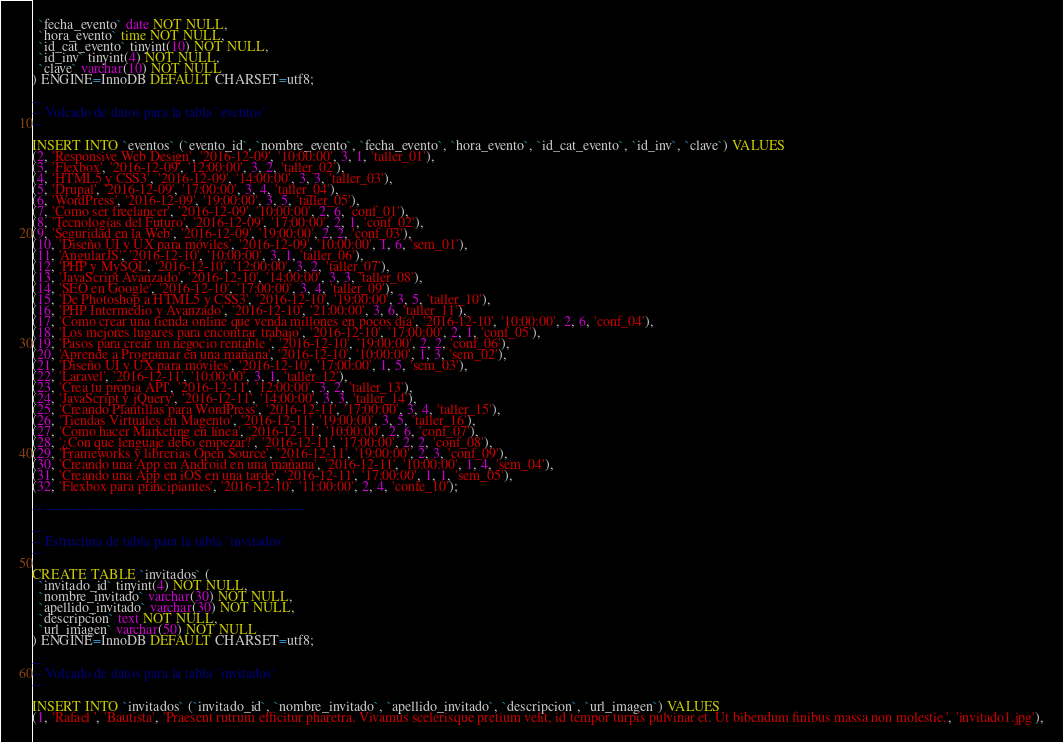Convert code to text. <code><loc_0><loc_0><loc_500><loc_500><_SQL_>  `fecha_evento` date NOT NULL,
  `hora_evento` time NOT NULL,
  `id_cat_evento` tinyint(10) NOT NULL,
  `id_inv` tinyint(4) NOT NULL,
  `clave` varchar(10) NOT NULL
) ENGINE=InnoDB DEFAULT CHARSET=utf8;

--
-- Volcado de datos para la tabla `eventos`
--

INSERT INTO `eventos` (`evento_id`, `nombre_evento`, `fecha_evento`, `hora_evento`, `id_cat_evento`, `id_inv`, `clave`) VALUES
(2, 'Responsive Web Design', '2016-12-09', '10:00:00', 3, 1, 'taller_01'),
(3, 'Flexbox', '2016-12-09', '12:00:00', 3, 2, 'taller_02'),
(4, 'HTML5 y CSS3', '2016-12-09', '14:00:00', 3, 3, 'taller_03'),
(5, 'Drupal', '2016-12-09', '17:00:00', 3, 4, 'taller_04'),
(6, 'WordPress', '2016-12-09', '19:00:00', 3, 5, 'taller_05'),
(7, 'Como ser freelancer', '2016-12-09', '10:00:00', 2, 6, 'conf_01'),
(8, 'Tecnologías del Futuro', '2016-12-09', '17:00:00', 2, 1, 'conf_02'),
(9, 'Seguridad en la Web', '2016-12-09', '19:00:00', 2, 2, 'conf_03'),
(10, 'Diseño UI y UX para móviles', '2016-12-09', '10:00:00', 1, 6, 'sem_01'),
(11, 'AngularJS', '2016-12-10', '10:00:00', 3, 1, 'taller_06'),
(12, 'PHP y MySQL', '2016-12-10', '12:00:00', 3, 2, 'taller_07'),
(13, 'JavaScript Avanzado', '2016-12-10', '14:00:00', 3, 3, 'taller_08'),
(14, 'SEO en Google', '2016-12-10', '17:00:00', 3, 4, 'taller_09'),
(15, 'De Photoshop a HTML5 y CSS3', '2016-12-10', '19:00:00', 3, 5, 'taller_10'),
(16, 'PHP Intermedio y Avanzado', '2016-12-10', '21:00:00', 3, 6, 'taller_11'),
(17, 'Como crear una tienda online que venda millones en pocos día', '2016-12-10', '10:00:00', 2, 6, 'conf_04'),
(18, 'Los mejores lugares para encontrar trabajo', '2016-12-10', '17:00:00', 2, 1, 'conf_05'),
(19, 'Pasos para crear un negocio rentable ', '2016-12-10', '19:00:00', 2, 2, 'conf_06'),
(20, 'Aprende a Programar en una mañana', '2016-12-10', '10:00:00', 1, 3, 'sem_02'),
(21, 'Diseño UI y UX para móviles', '2016-12-10', '17:00:00', 1, 5, 'sem_03'),
(22, 'Laravel', '2016-12-11', '10:00:00', 3, 1, 'taller_12'),
(23, 'Crea tu propia API', '2016-12-11', '12:00:00', 3, 2, 'taller_13'),
(24, 'JavaScript y jQuery', '2016-12-11', '14:00:00', 3, 3, 'taller_14'),
(25, 'Creando Plantillas para WordPress', '2016-12-11', '17:00:00', 3, 4, 'taller_15'),
(26, 'Tiendas Virtuales en Magento', '2016-12-11', '19:00:00', 3, 5, 'taller_16'),
(27, 'Como hacer Marketing en línea', '2016-12-11', '10:00:00', 2, 6, 'conf_07'),
(28, '¿Con que lenguaje debo empezar?', '2016-12-11', '17:00:00', 2, 2, 'conf_08'),
(29, 'Frameworks y librerias Open Source', '2016-12-11', '19:00:00', 2, 3, 'conf_09'),
(30, 'Creando una App en Android en una mañana', '2016-12-11', '10:00:00', 1, 4, 'sem_04'),
(31, 'Creando una App en iOS en una tarde', '2016-12-11', '17:00:00', 1, 1, 'sem_05'),
(32, 'Flexbox para principiantes', '2016-12-10', '11:00:00', 2, 4, 'confe_10');

-- --------------------------------------------------------

--
-- Estructura de tabla para la tabla `invitados`
--

CREATE TABLE `invitados` (
  `invitado_id` tinyint(4) NOT NULL,
  `nombre_invitado` varchar(30) NOT NULL,
  `apellido_invitado` varchar(30) NOT NULL,
  `descripcion` text NOT NULL,
  `url_imagen` varchar(50) NOT NULL
) ENGINE=InnoDB DEFAULT CHARSET=utf8;

--
-- Volcado de datos para la tabla `invitados`
--

INSERT INTO `invitados` (`invitado_id`, `nombre_invitado`, `apellido_invitado`, `descripcion`, `url_imagen`) VALUES
(1, 'Rafael ', 'Bautista', 'Praesent rutrum efficitur pharetra. Vivamus scelerisque pretium velit, id tempor turpis pulvinar et. Ut bibendum finibus massa non molestie.', 'invitado1.jpg'),</code> 